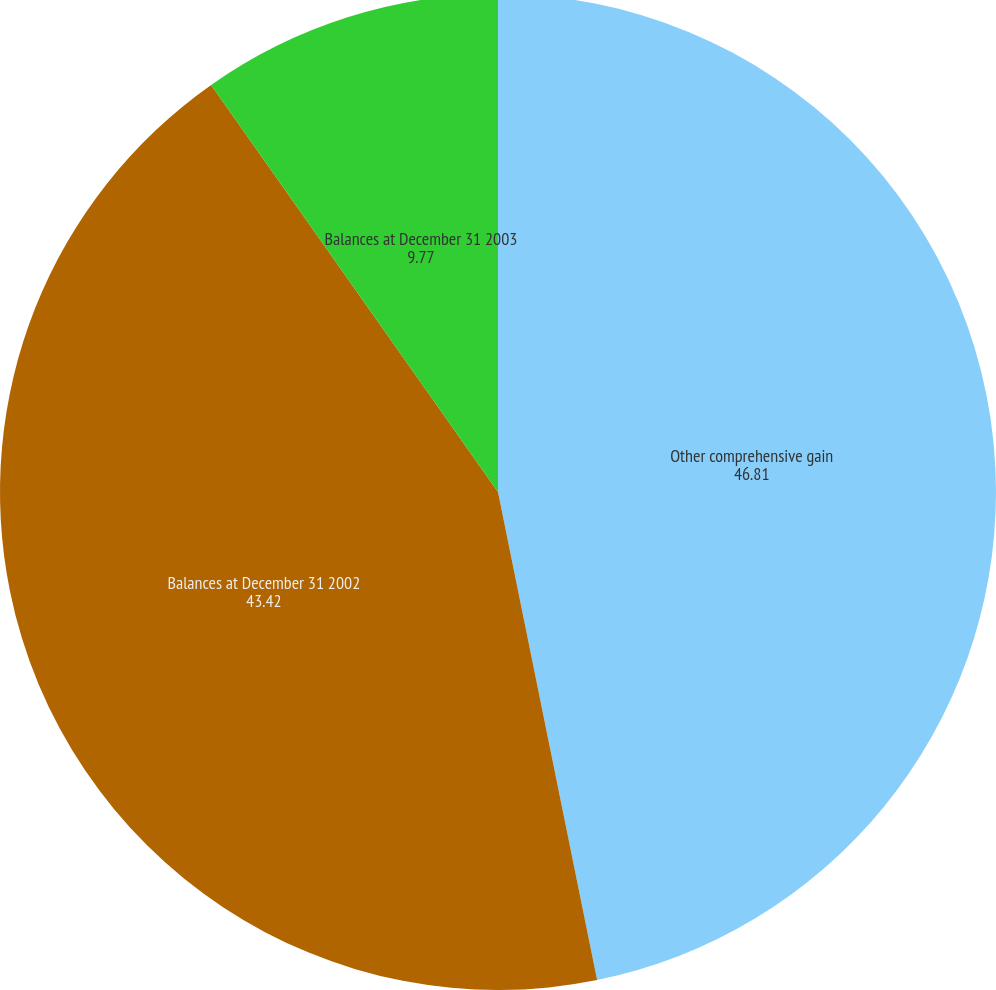Convert chart to OTSL. <chart><loc_0><loc_0><loc_500><loc_500><pie_chart><fcel>Other comprehensive gain<fcel>Balances at December 31 2002<fcel>Balances at December 31 2003<nl><fcel>46.81%<fcel>43.42%<fcel>9.77%<nl></chart> 